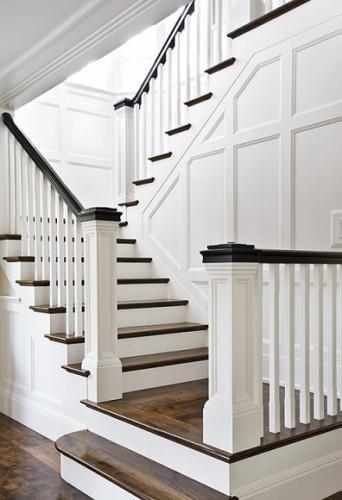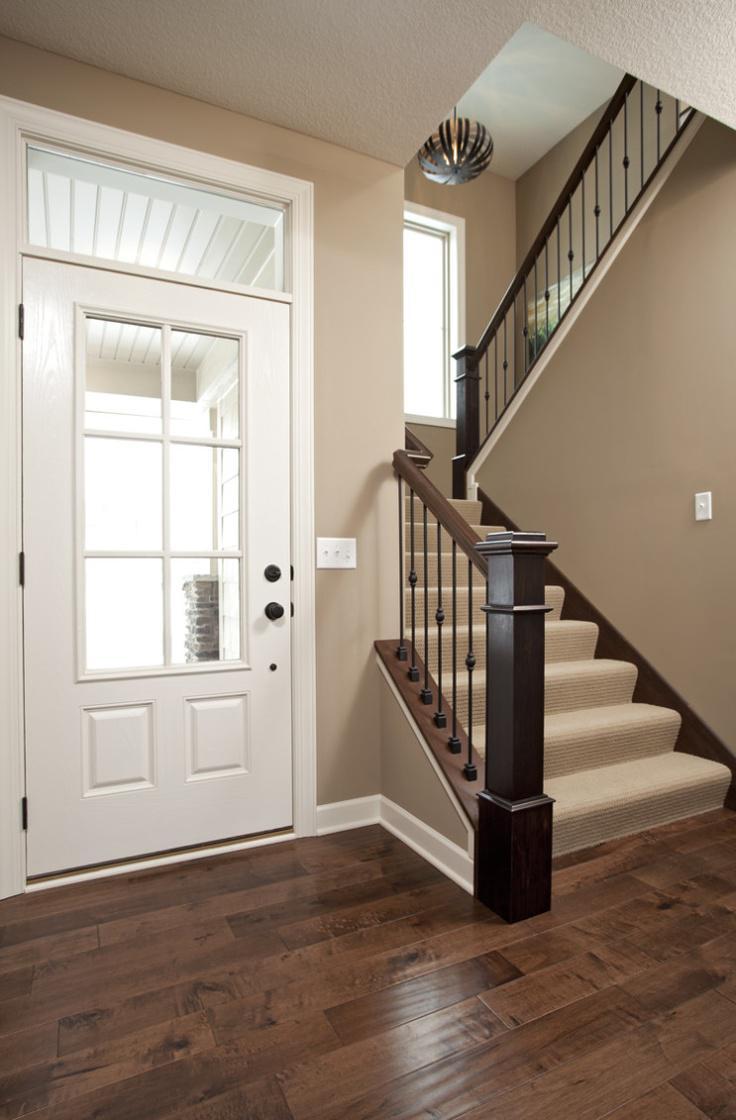The first image is the image on the left, the second image is the image on the right. Given the left and right images, does the statement "In at least on image there a two level empty staircase with a black handle and with rodes to protect someone from falling off." hold true? Answer yes or no. Yes. The first image is the image on the left, the second image is the image on the right. Examine the images to the left and right. Is the description "One image shows a cream-carpeted staircase that starts at the lower right, ascends, and turns back to the right, with a light fixture suspended over it." accurate? Answer yes or no. Yes. 